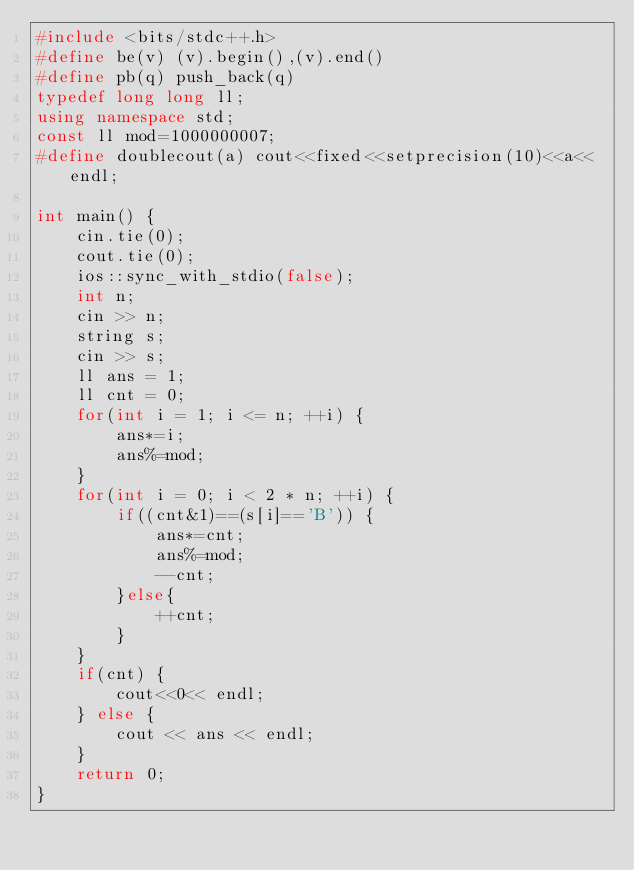Convert code to text. <code><loc_0><loc_0><loc_500><loc_500><_C++_>#include <bits/stdc++.h>
#define be(v) (v).begin(),(v).end()
#define pb(q) push_back(q)
typedef long long ll;
using namespace std;
const ll mod=1000000007;
#define doublecout(a) cout<<fixed<<setprecision(10)<<a<<endl;

int main() {
    cin.tie(0);
    cout.tie(0);
    ios::sync_with_stdio(false);
    int n;
    cin >> n;
    string s;
    cin >> s;
    ll ans = 1;
    ll cnt = 0;
    for(int i = 1; i <= n; ++i) {
        ans*=i;
        ans%=mod;
    }
    for(int i = 0; i < 2 * n; ++i) {
        if((cnt&1)==(s[i]=='B')) {
            ans*=cnt;
            ans%=mod;
            --cnt;
        }else{
            ++cnt;
        }
    }
    if(cnt) {
        cout<<0<< endl;
    } else {
        cout << ans << endl;
    }
    return 0;
}

</code> 